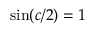Convert formula to latex. <formula><loc_0><loc_0><loc_500><loc_500>\sin ( c / 2 ) = 1</formula> 